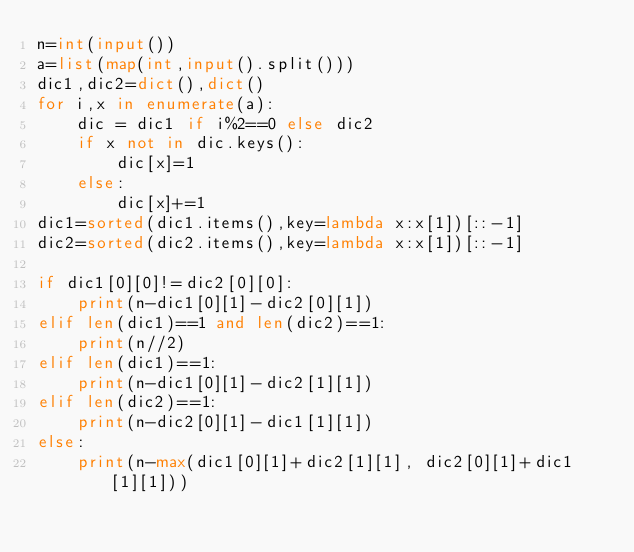Convert code to text. <code><loc_0><loc_0><loc_500><loc_500><_Python_>n=int(input())
a=list(map(int,input().split()))
dic1,dic2=dict(),dict()
for i,x in enumerate(a):
    dic = dic1 if i%2==0 else dic2
    if x not in dic.keys():
        dic[x]=1
    else:
        dic[x]+=1
dic1=sorted(dic1.items(),key=lambda x:x[1])[::-1]
dic2=sorted(dic2.items(),key=lambda x:x[1])[::-1]

if dic1[0][0]!=dic2[0][0]:
    print(n-dic1[0][1]-dic2[0][1])
elif len(dic1)==1 and len(dic2)==1:
    print(n//2)
elif len(dic1)==1:
    print(n-dic1[0][1]-dic2[1][1])
elif len(dic2)==1:
    print(n-dic2[0][1]-dic1[1][1])
else:
    print(n-max(dic1[0][1]+dic2[1][1], dic2[0][1]+dic1[1][1]))</code> 